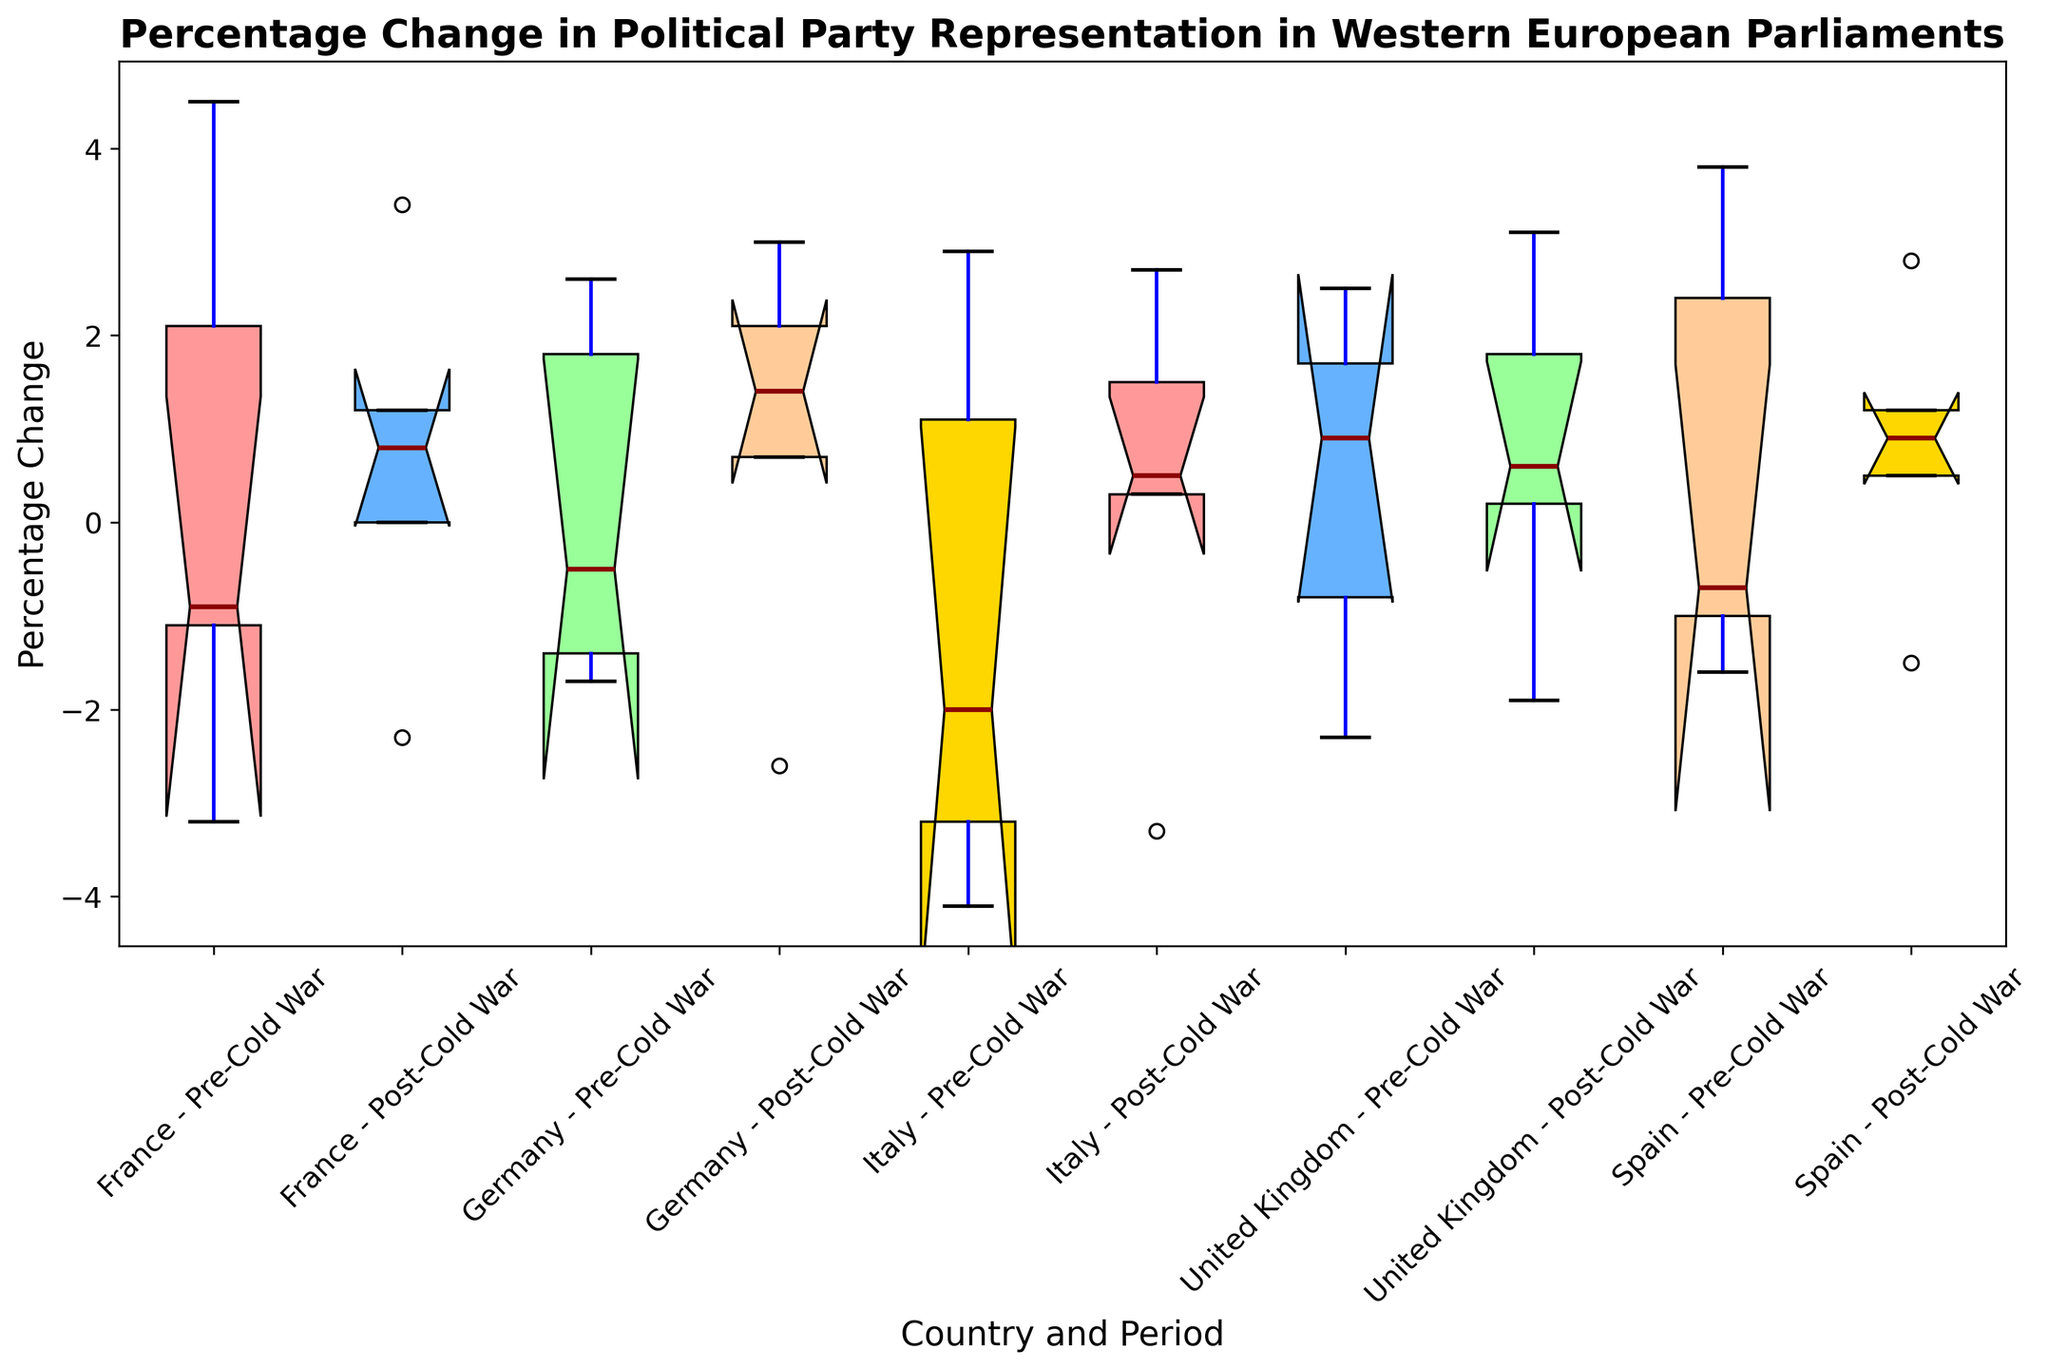What is the median percentage change for France in the Post-Cold War period? Locate the box for "France - Post-Cold War". The red line inside the box represents the median value.
Answer: 0.8 Which country had the highest maximum percentage change in the Pre-Cold War period? Look at the upper whiskers of the boxes for all countries labeled as "Pre-Cold War" and identify the country with the highest position whisker.
Answer: Spain Which period, Pre-Cold War or Post-Cold War, had a higher median percentage change in Germany? Compare the red median lines for "Germany - Pre-Cold War" and "Germany - Post-Cold War". The Post-Cold War median line is higher.
Answer: Post-Cold War What is the interquartile range (IQR) for the United Kingdom in the Pre-Cold War period? Locate the box plot for "United Kingdom - Pre-Cold War". The IQR is represented by the height of the box (difference between the top and bottom of the box). Find the values corresponding to the top and bottom edges of the box, and subtract the lower quartile from the upper quartile.
Answer: [Upper Quartile - Lower Quartile] Compare the spread of percentage changes for Italy in the Post-Cold War and Pre-Cold War periods. Which period has a wider spread? Examine the whiskers and the range of the boxes for Italy in both periods. The period with a longer whisker or larger box height indicates a wider spread.
Answer: Post-Cold War Which country showed the most consistent percentage changes (smallest spread) in the Post-Cold War period? Identify the boxes for each country during the Post-Cold War period and compare their spread by examining the height of the box plots and the whiskers. The country with the smallest box and whiskers has the most consistent changes.
Answer: France What is the difference in the median percentage changes for Spain Pre- and Post-Cold War? Look at the red median lines for "Spain - Pre-Cold War" and "Spain - Post-Cold War" and subtract the Pre-Cold War median from the Post-Cold War median.
Answer: [Post-Cold War Median - Pre-Cold War Median] For which country does the interquartile range (IQR) increase from the Pre-Cold War to the Post-Cold War period? Calculate the IQR for each country in both periods by measuring the box heights and compare the IQRs. Identify the country where the box height increases in the Post-Cold War period.
Answer: [Country Name] 